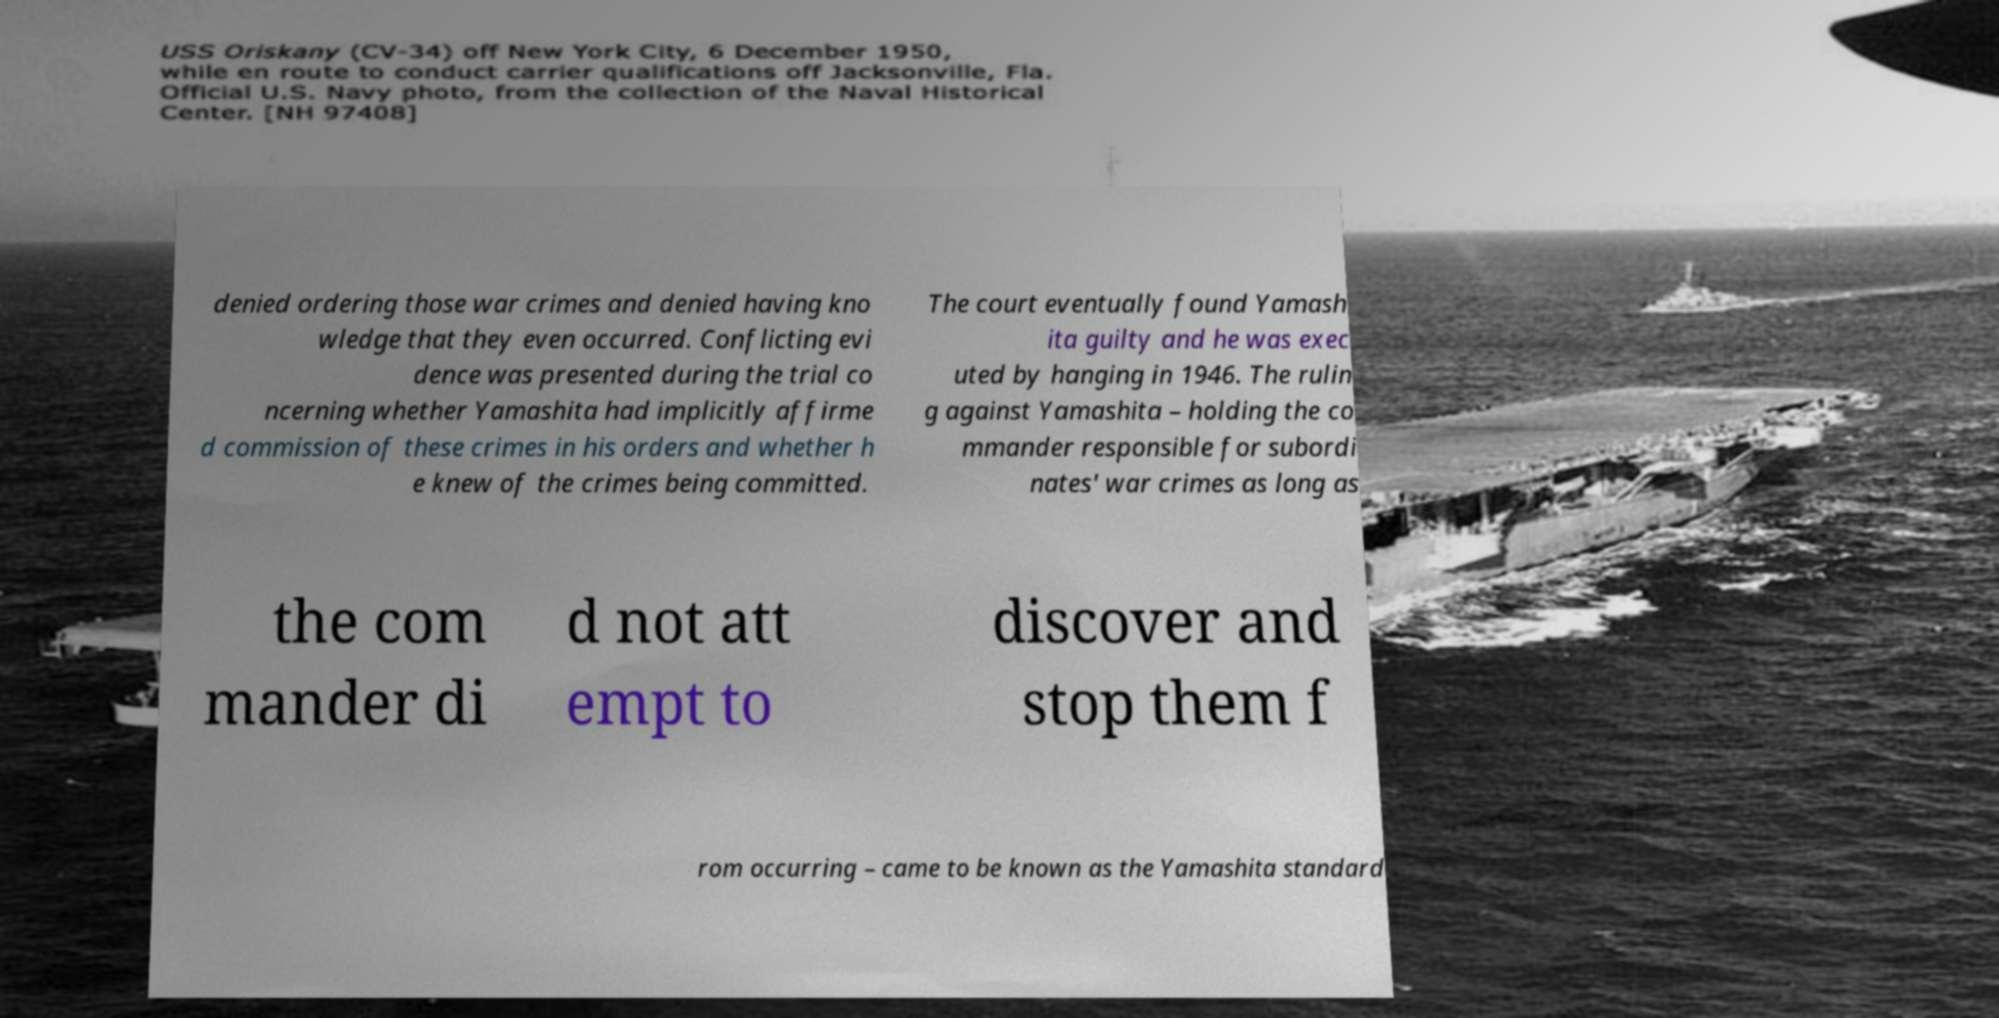Could you extract and type out the text from this image? denied ordering those war crimes and denied having kno wledge that they even occurred. Conflicting evi dence was presented during the trial co ncerning whether Yamashita had implicitly affirme d commission of these crimes in his orders and whether h e knew of the crimes being committed. The court eventually found Yamash ita guilty and he was exec uted by hanging in 1946. The rulin g against Yamashita – holding the co mmander responsible for subordi nates' war crimes as long as the com mander di d not att empt to discover and stop them f rom occurring – came to be known as the Yamashita standard 